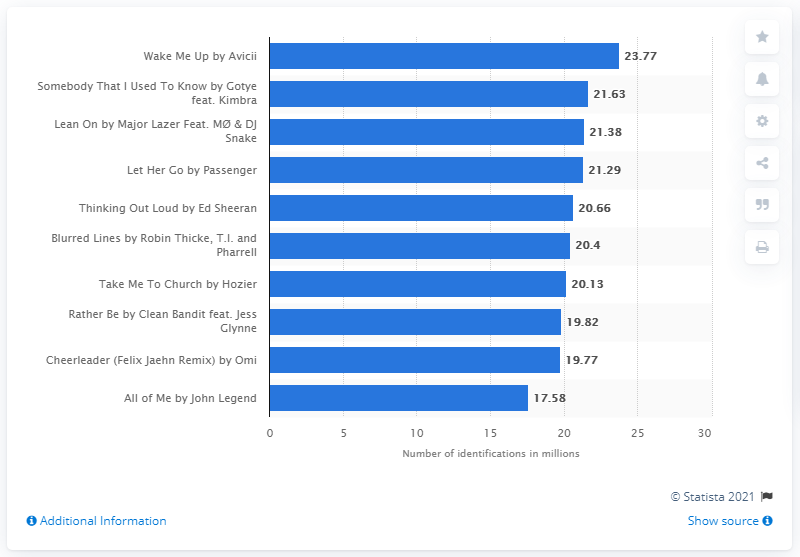Draw attention to some important aspects in this diagram. Shazam identified the song "Wake Me Up" by Avicii a total of 23.77 times. 